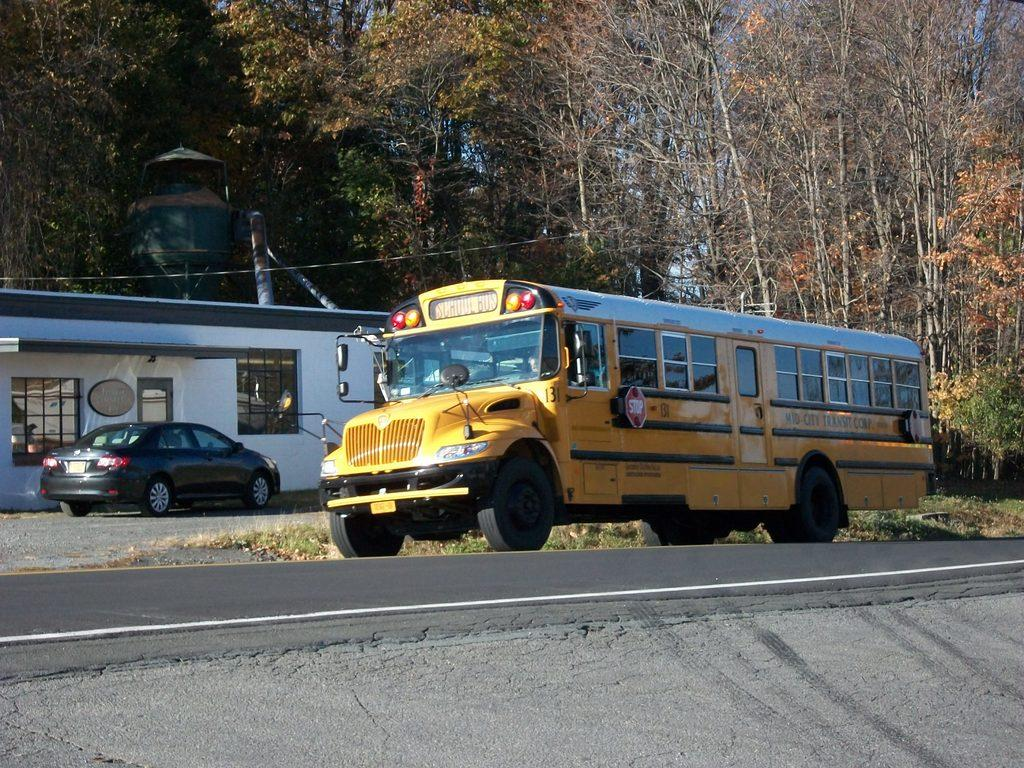What type of building is visible in the image? There is a house in the image. What vehicles can be seen in the image? There is a car and a truck in the image. What type of vegetation is present in the image? There are trees in the image. Reasoning: Let's think step by following the guidelines to produce the conversation. We start by identifying the main subjects in the image, which are the house, car, truck, and trees. Then, we formulate questions that focus on the type of each subject, ensuring that each question can be answered definitively with the information given. We avoid yes/no questions and ensure that the language is simple and clear. Absurd Question/Answer: What color is the sweater worn by the jellyfish in the image? There is no jellyfish or sweater present in the image. Is there any poison visible in the image? There is no poison present in the image. 